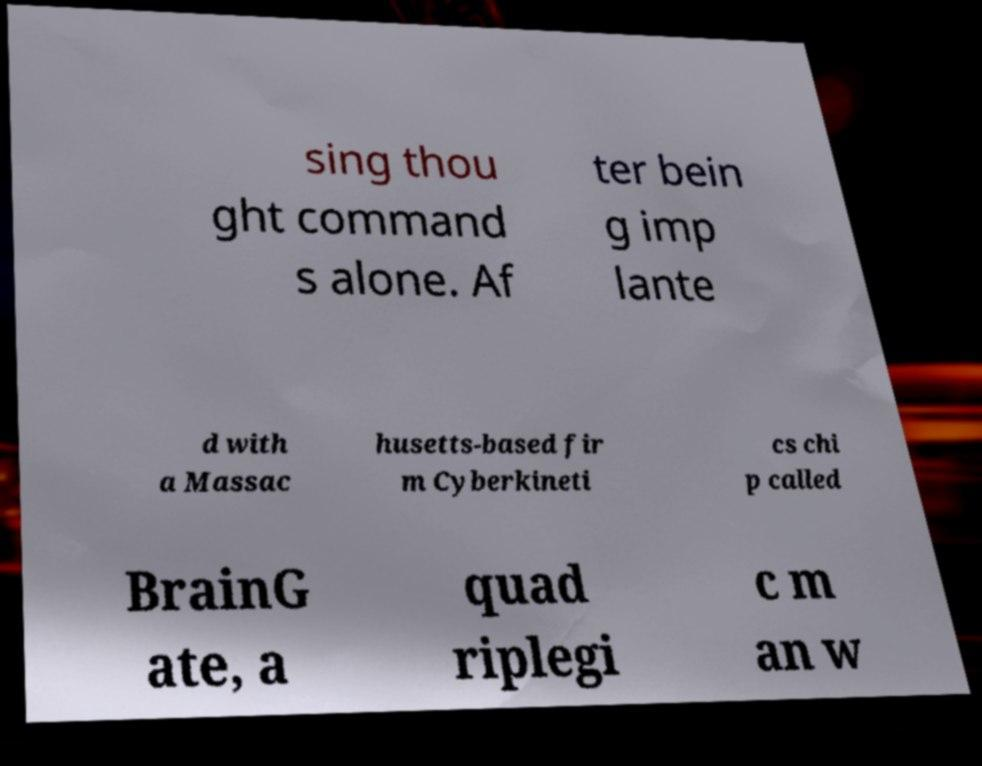Please identify and transcribe the text found in this image. sing thou ght command s alone. Af ter bein g imp lante d with a Massac husetts-based fir m Cyberkineti cs chi p called BrainG ate, a quad riplegi c m an w 